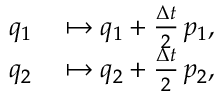Convert formula to latex. <formula><loc_0><loc_0><loc_500><loc_500>\begin{array} { r l } { q _ { 1 } } & \mapsto q _ { 1 } + \frac { \Delta t } { 2 } \, p _ { 1 } , } \\ { q _ { 2 } } & \mapsto q _ { 2 } + \frac { \Delta t } { 2 } \, p _ { 2 } , } \end{array}</formula> 